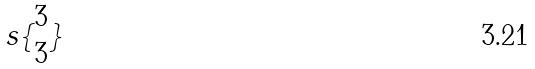Convert formula to latex. <formula><loc_0><loc_0><loc_500><loc_500>s \{ \begin{matrix} 3 \\ 3 \end{matrix} \}</formula> 